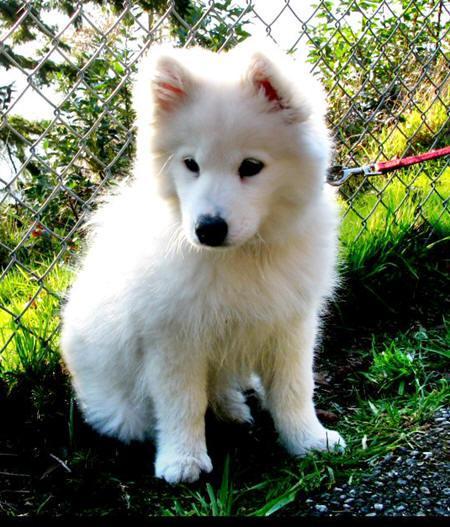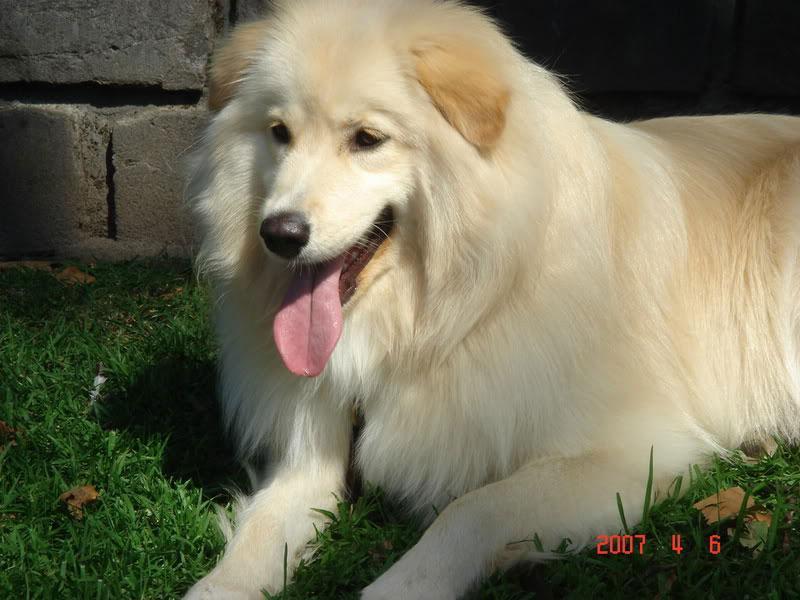The first image is the image on the left, the second image is the image on the right. Given the left and right images, does the statement "there is a dog standing on the grass with a row of trees behind it" hold true? Answer yes or no. No. The first image is the image on the left, the second image is the image on the right. Examine the images to the left and right. Is the description "Two dogs are in a grassy area in the image on the right." accurate? Answer yes or no. No. 